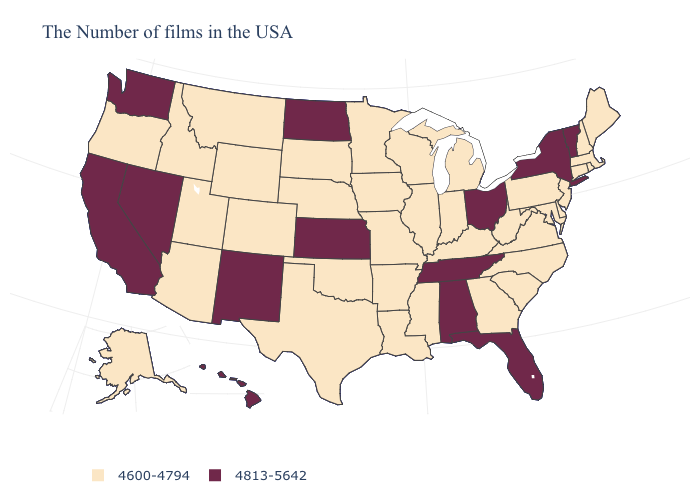How many symbols are there in the legend?
Quick response, please. 2. What is the value of Arkansas?
Keep it brief. 4600-4794. What is the highest value in states that border Indiana?
Keep it brief. 4813-5642. Name the states that have a value in the range 4600-4794?
Answer briefly. Maine, Massachusetts, Rhode Island, New Hampshire, Connecticut, New Jersey, Delaware, Maryland, Pennsylvania, Virginia, North Carolina, South Carolina, West Virginia, Georgia, Michigan, Kentucky, Indiana, Wisconsin, Illinois, Mississippi, Louisiana, Missouri, Arkansas, Minnesota, Iowa, Nebraska, Oklahoma, Texas, South Dakota, Wyoming, Colorado, Utah, Montana, Arizona, Idaho, Oregon, Alaska. Name the states that have a value in the range 4813-5642?
Keep it brief. Vermont, New York, Ohio, Florida, Alabama, Tennessee, Kansas, North Dakota, New Mexico, Nevada, California, Washington, Hawaii. What is the value of Maryland?
Write a very short answer. 4600-4794. Name the states that have a value in the range 4813-5642?
Write a very short answer. Vermont, New York, Ohio, Florida, Alabama, Tennessee, Kansas, North Dakota, New Mexico, Nevada, California, Washington, Hawaii. Does the first symbol in the legend represent the smallest category?
Answer briefly. Yes. Which states have the highest value in the USA?
Answer briefly. Vermont, New York, Ohio, Florida, Alabama, Tennessee, Kansas, North Dakota, New Mexico, Nevada, California, Washington, Hawaii. What is the highest value in states that border West Virginia?
Quick response, please. 4813-5642. Name the states that have a value in the range 4600-4794?
Short answer required. Maine, Massachusetts, Rhode Island, New Hampshire, Connecticut, New Jersey, Delaware, Maryland, Pennsylvania, Virginia, North Carolina, South Carolina, West Virginia, Georgia, Michigan, Kentucky, Indiana, Wisconsin, Illinois, Mississippi, Louisiana, Missouri, Arkansas, Minnesota, Iowa, Nebraska, Oklahoma, Texas, South Dakota, Wyoming, Colorado, Utah, Montana, Arizona, Idaho, Oregon, Alaska. Does New Hampshire have the highest value in the Northeast?
Short answer required. No. What is the lowest value in the MidWest?
Concise answer only. 4600-4794. Among the states that border Kentucky , which have the lowest value?
Quick response, please. Virginia, West Virginia, Indiana, Illinois, Missouri. What is the value of Michigan?
Give a very brief answer. 4600-4794. 